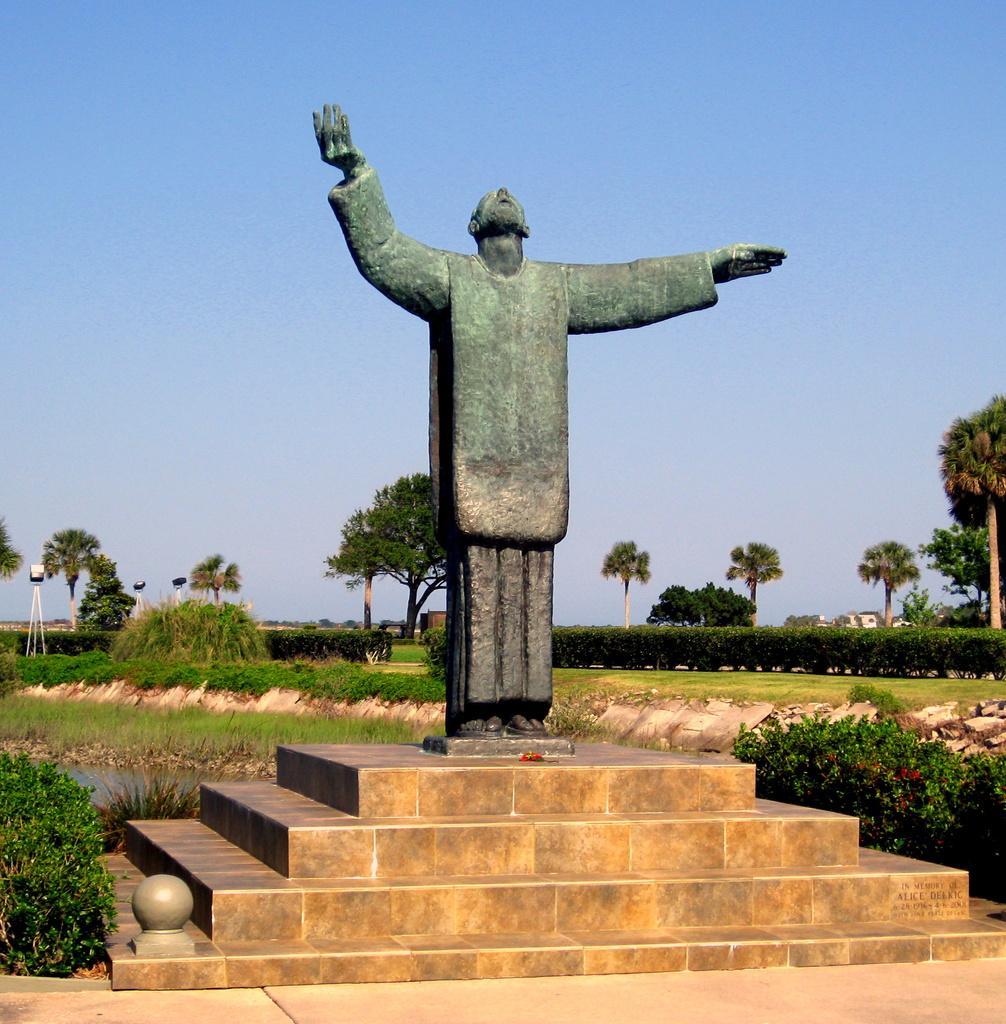How would you summarize this image in a sentence or two? In this picture we can see statue of a person, above this stairs. On the right we can see plants. In the background we can see many trees, plants, grass, farm land, poles and a building. On the top there is a sky. 